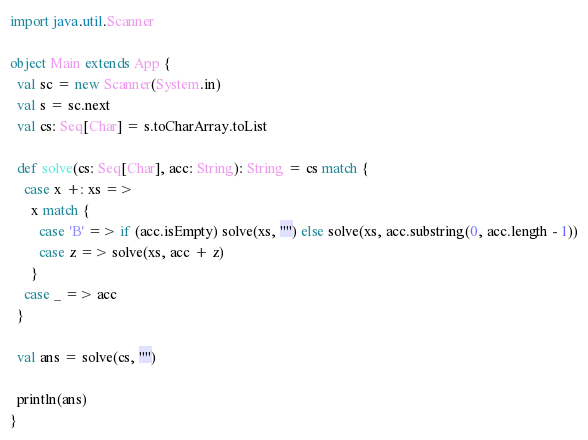<code> <loc_0><loc_0><loc_500><loc_500><_Scala_>
import java.util.Scanner

object Main extends App {
  val sc = new Scanner(System.in)
  val s = sc.next
  val cs: Seq[Char] = s.toCharArray.toList

  def solve(cs: Seq[Char], acc: String): String = cs match {
    case x +: xs =>
      x match {
        case 'B' => if (acc.isEmpty) solve(xs, "") else solve(xs, acc.substring(0, acc.length - 1))
        case z => solve(xs, acc + z)
      }
    case _ => acc
  }

  val ans = solve(cs, "")

  println(ans)
}
</code> 